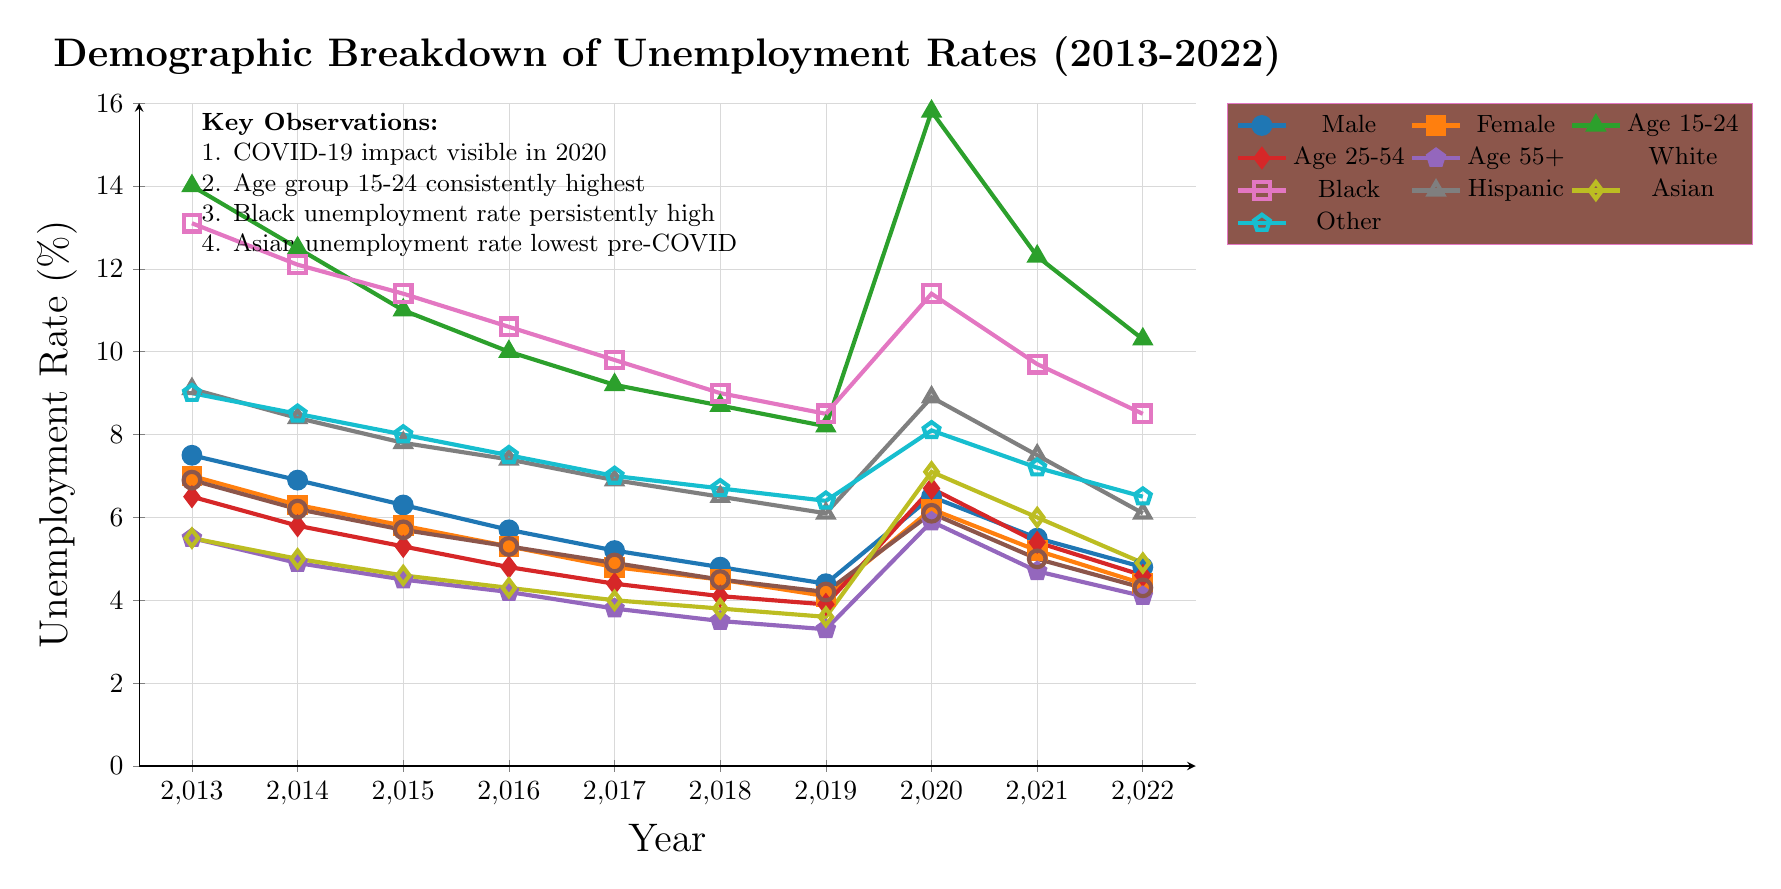What was the unemployment rate for males in 2020? By locating the data for the year 2020 on the male unemployment line in the diagram, the value shown is 6.5 percent.
Answer: 6.5 Which demographic had the lowest unemployment rate in 2019? In the diagram, the unemployment rates for different demographics in 2019 are compared; the Asian demographic has the lowest rate, which is 3.6 percent.
Answer: Asian What trend is observed in the unemployment rate for the age group 15-24 from 2013 to 2022? Upon examining the area chart for the age group 15-24, it can be seen that the unemployment rate decreases overall from 14.0 percent in 2013 to 10.3 percent in 2022, with a significant spike in 2020 due to the COVID-19 pandemic.
Answer: Decreasing What is the unemployment rate of Black individuals in 2018? The data point for Black individuals in 2018 shows an unemployment rate of 9.0 percent, identifiable by locating the corresponding line and checking the value for that year.
Answer: 9.0 In which year did the unemployment rate for females drop below 5 percent for the first time? By analyzing the unemployment rates for females, it can be determined that the rate first dropped below 5 percent in 2018, with a rate of 4.5 percent noted on the chart.
Answer: 2018 What is the highlight for the demographic labeled "Other"? Reviewing the key observations noted on the diagram, there is mention that the unemployment rate for the "Other" demographic had a consistent trend every year, indicating stability in comparisons with other groups.
Answer: Consistent How did the COVID-19 pandemic affect the unemployment rates across demographics in 2020? The diagram captures a dramatic increase in unemployment rates for nearly all demographics in 2020 compared to 2019; specifically, the age group 15-24 saw a spike to 15.8 percent, indicating a severe impact due to the pandemic.
Answer: Spike in 2020 What was the highest recorded unemployment rate in the diagram for any demographic? Assessing the various unemployment rates across demographics, the highest recorded rate was 14.0 percent for the age group 15-24 in 2013.
Answer: 14.0 Which race experienced the largest decrease in unemployment rate from 2013 to 2022? Evaluating the rates from 2013 to 2022, the demographic labeled "Asian" shows a decrease from 5.5 percent to 4.9 percent, indicating the largest relative stability compared to other groups.
Answer: Asian 